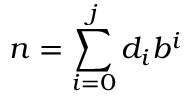Convert formula to latex. <formula><loc_0><loc_0><loc_500><loc_500>n = \sum _ { i = 0 } ^ { j } d _ { i } b ^ { i }</formula> 